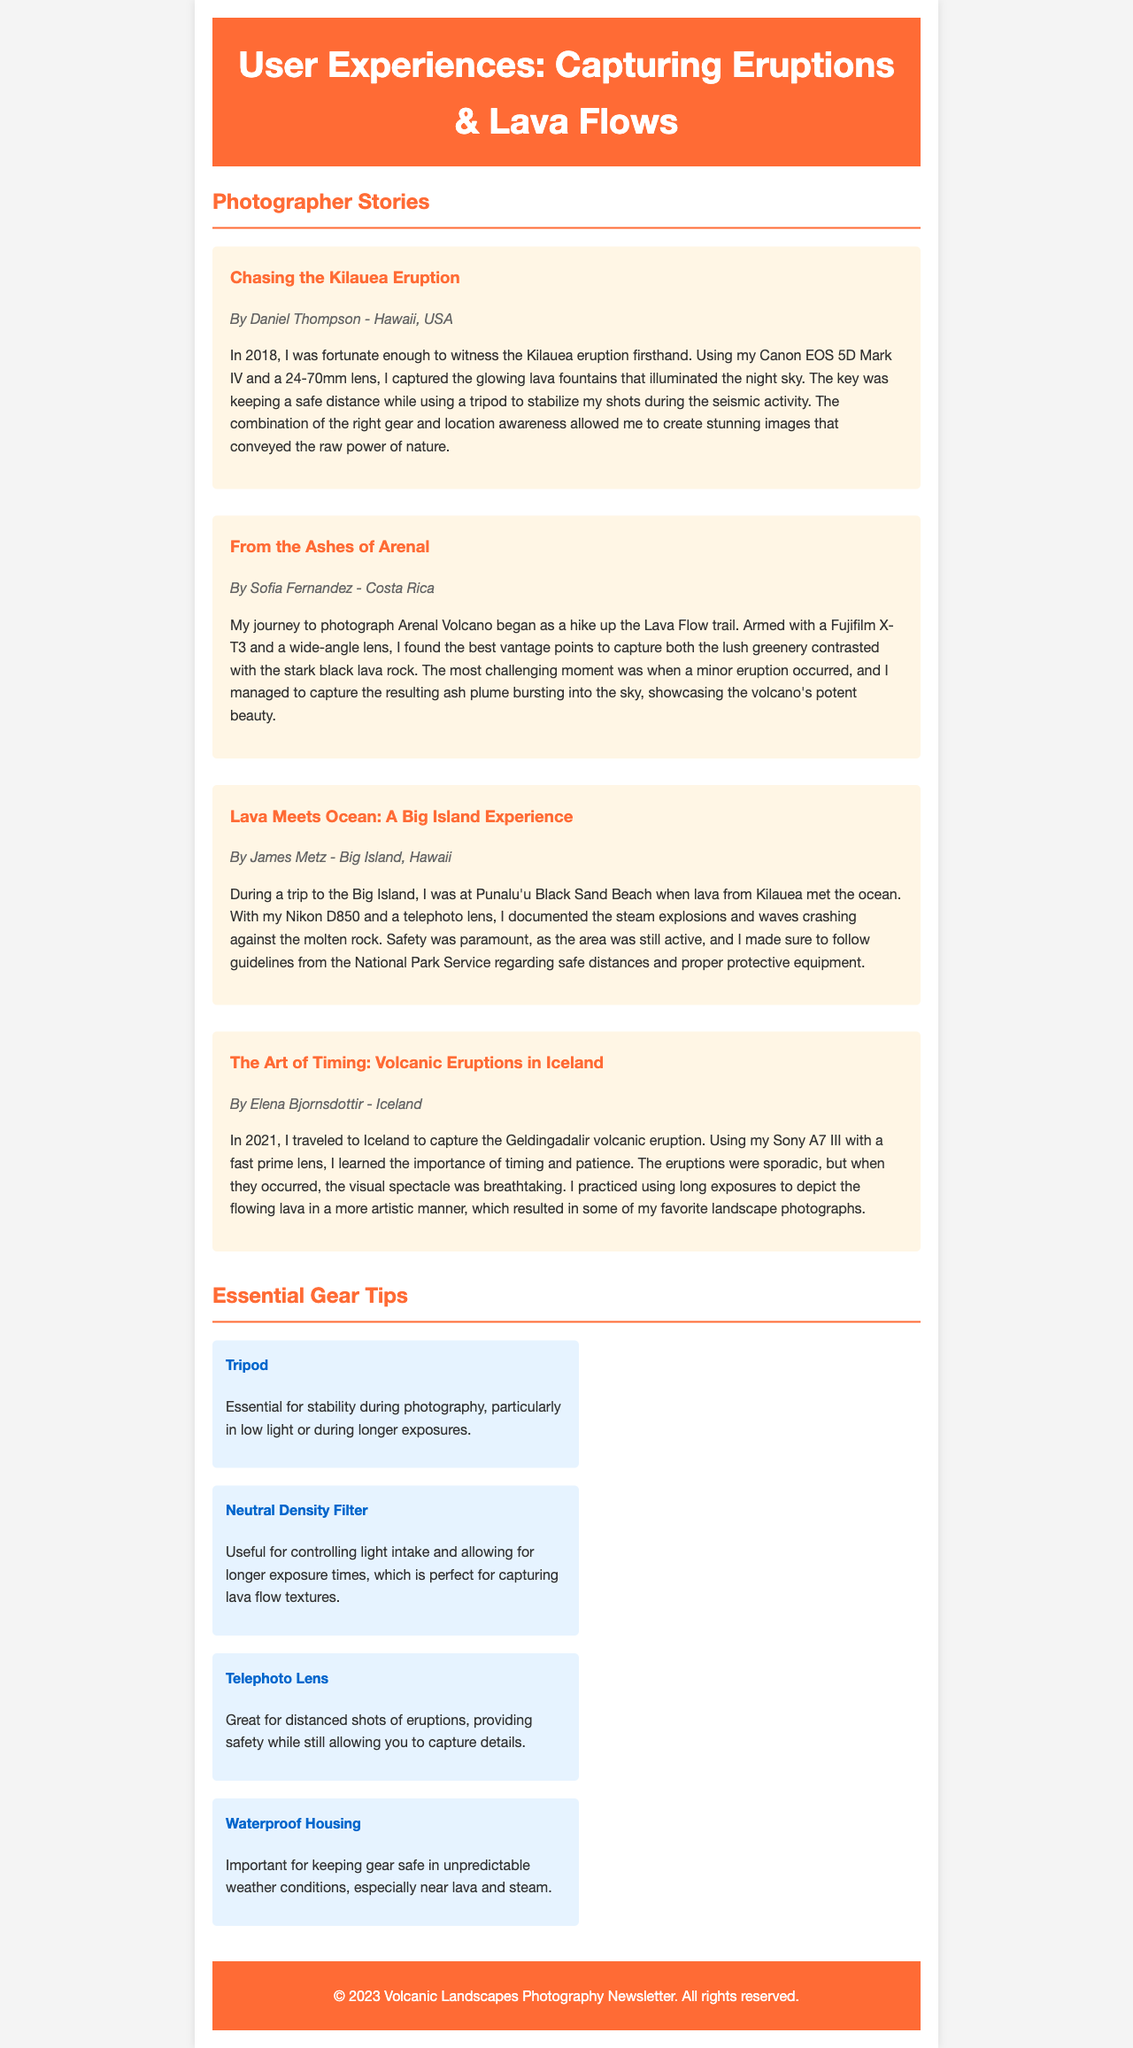What is the title of the newsletter? The title is stated at the top of the document within the header section.
Answer: User Experiences: Capturing Eruptions & Lava Flows Who photographed the Kilauea eruption? The author of the article about Kilauea is identified in the author info section.
Answer: Daniel Thompson Which camera was used by Sofia Fernandez? The document specifies the camera used by Sofia within her story.
Answer: Fujifilm X-T3 What is one essential gear tip listed in the newsletter? The document provides a section with various tips essential for volcanic photography.
Answer: Tripod How many photographers shared their experiences in the newsletter? By counting the individual articles in the photographer stories section, we determine the total.
Answer: Four What year did Elena Bjornsdottir travel to Iceland? The information about the travel year is noted within her article.
Answer: 2021 What type of lens is recommended for capturing lava flows? The document includes gear tips that specify useful equipment for such photography.
Answer: Neutral Density Filter Which location did James Metz document during his photography trip? The location mentioned in James Metz's article is explicitly stated.
Answer: Punalu'u Black Sand Beach What's the primary focus of the newsletter? The main theme can be inferred from the title and content sections included in the document.
Answer: Volcanic Landscapes Photography 